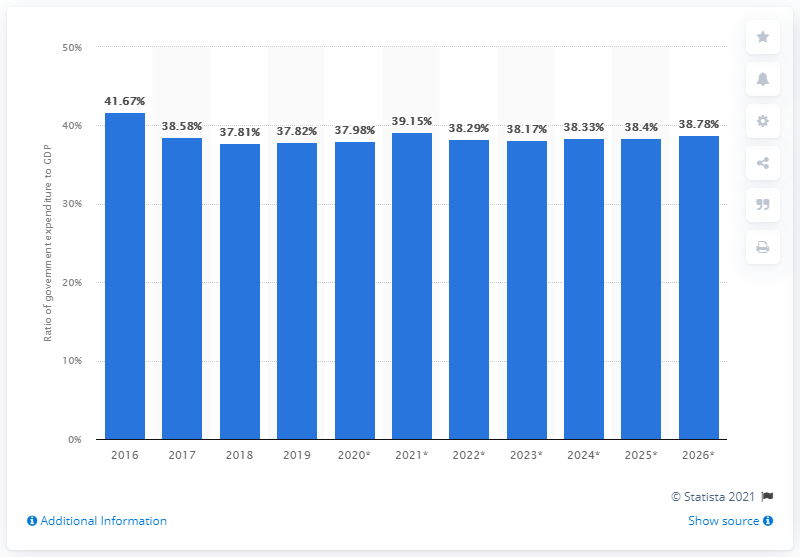List a handful of essential elements in this visual. In 2019, government expenditure accounted for 38.17% of Algeria's GDP. 